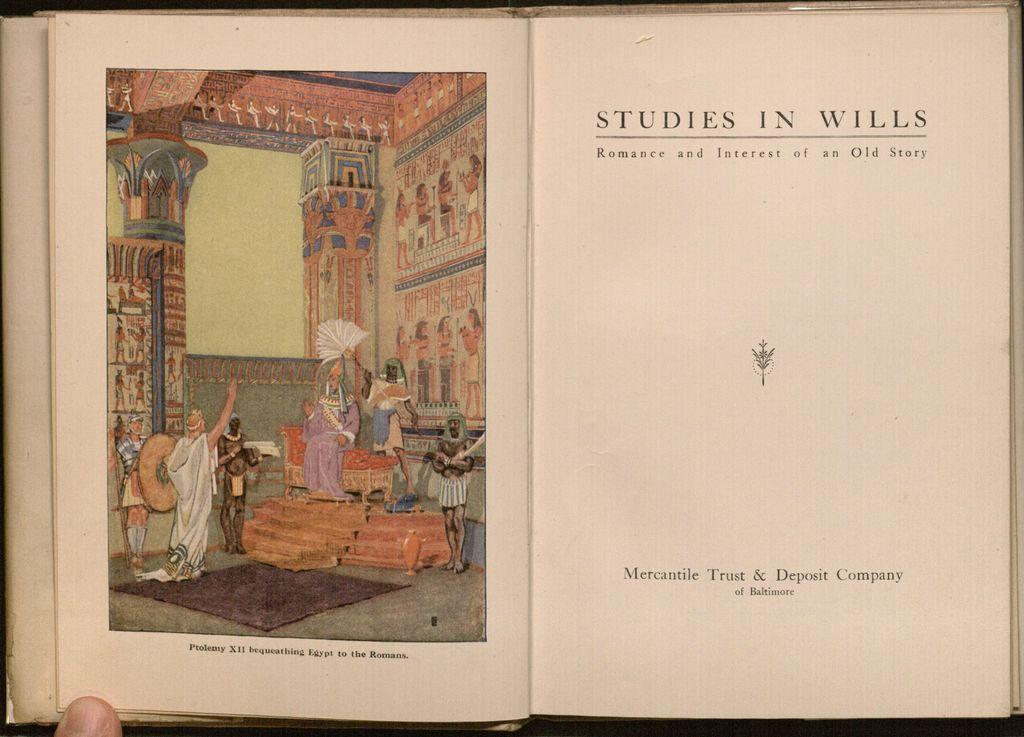<image>
Provide a brief description of the given image. an open copy of the book studies in wills. 